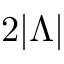Convert formula to latex. <formula><loc_0><loc_0><loc_500><loc_500>2 | \Lambda |</formula> 